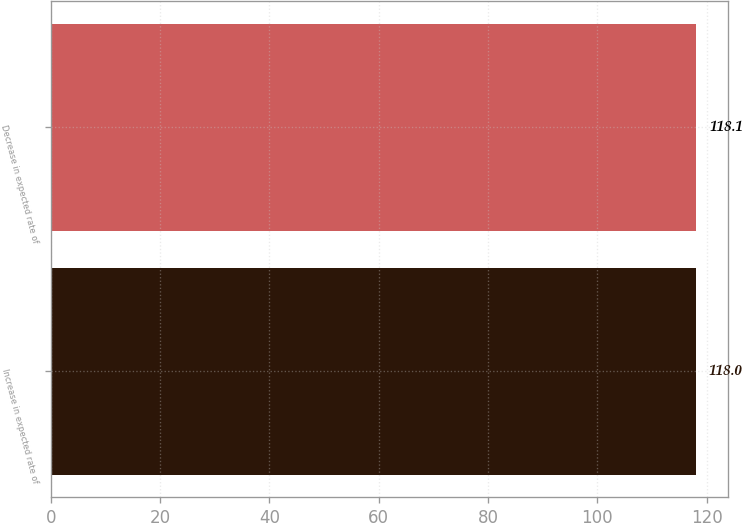Convert chart. <chart><loc_0><loc_0><loc_500><loc_500><bar_chart><fcel>Increase in expected rate of<fcel>Decrease in expected rate of<nl><fcel>118<fcel>118.1<nl></chart> 